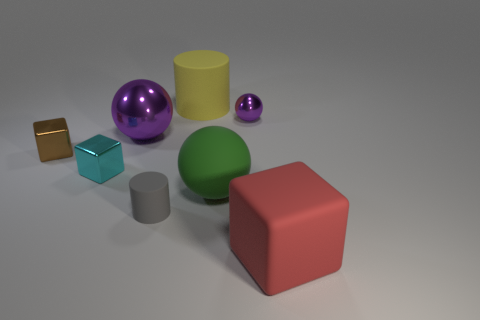What materials do the objects in the image appear to be made of? The objects appear to have varying materials. The shiny purple and smaller green spheres suggest a polished metallic or glass surface. The yellow cylinder looks like dull plastic, while the blue cube has a reflective, possibly metallic texture. The large red cube seems to have a matte surface, possibly plastic or painted wood, and the smaller brown cube appears to have a gold-like reflective surface. 